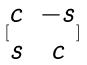Convert formula to latex. <formula><loc_0><loc_0><loc_500><loc_500>[ \begin{matrix} c & - s \\ s & c \end{matrix} ]</formula> 